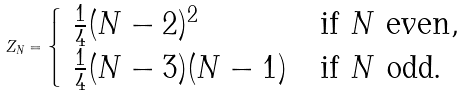Convert formula to latex. <formula><loc_0><loc_0><loc_500><loc_500>Z _ { N } = \begin{cases} \ \frac { 1 } { 4 } ( N - 2 ) ^ { 2 } & \text {if } N \text { even} , \\ \ \frac { 1 } { 4 } ( N - 3 ) ( N - 1 ) & \text {if } N \text { odd.} \end{cases}</formula> 